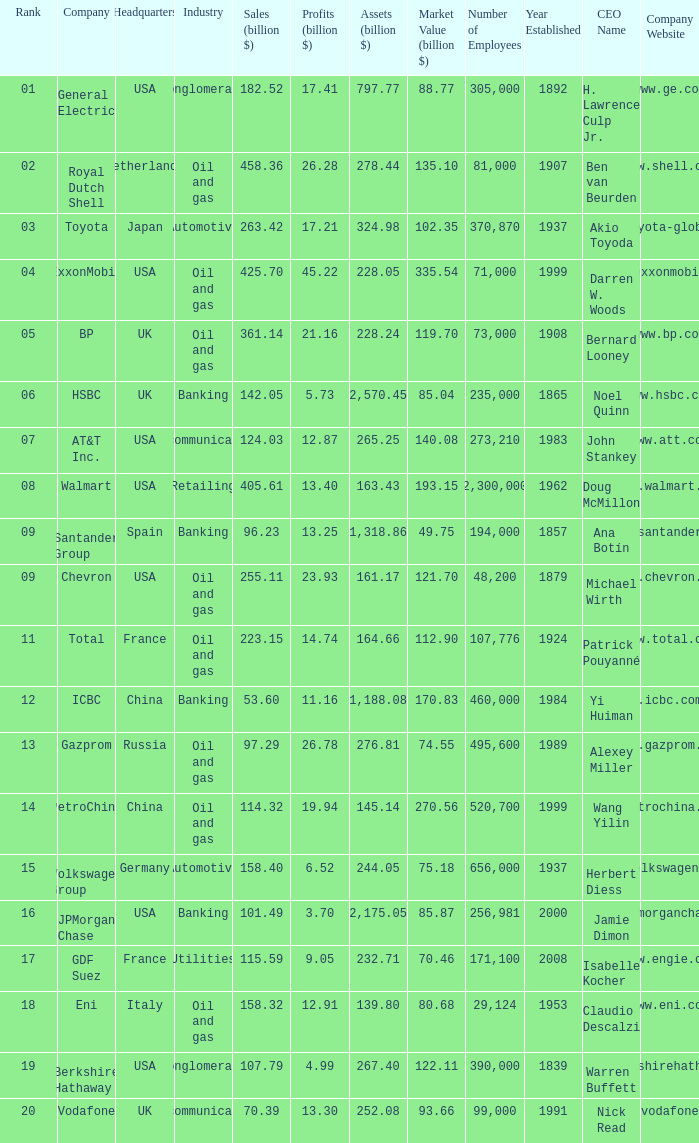Name the lowest Market Value (billion $) which has Assets (billion $) larger than 276.81, and a Company of toyota, and Profits (billion $) larger than 17.21? None. 